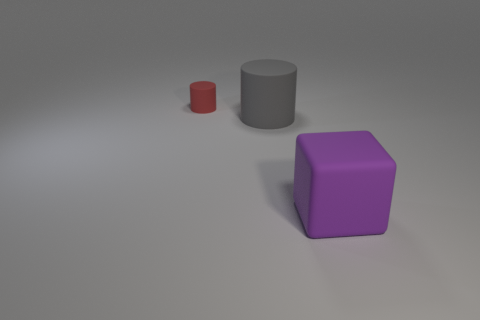Add 2 small brown objects. How many objects exist? 5 Subtract 0 yellow cylinders. How many objects are left? 3 Subtract all cylinders. How many objects are left? 1 Subtract all cyan cubes. Subtract all gray balls. How many cubes are left? 1 Subtract all gray cylinders. How many red cubes are left? 0 Subtract all red matte cylinders. Subtract all green rubber cylinders. How many objects are left? 2 Add 2 big blocks. How many big blocks are left? 3 Add 3 tiny cylinders. How many tiny cylinders exist? 4 Subtract all gray cylinders. How many cylinders are left? 1 